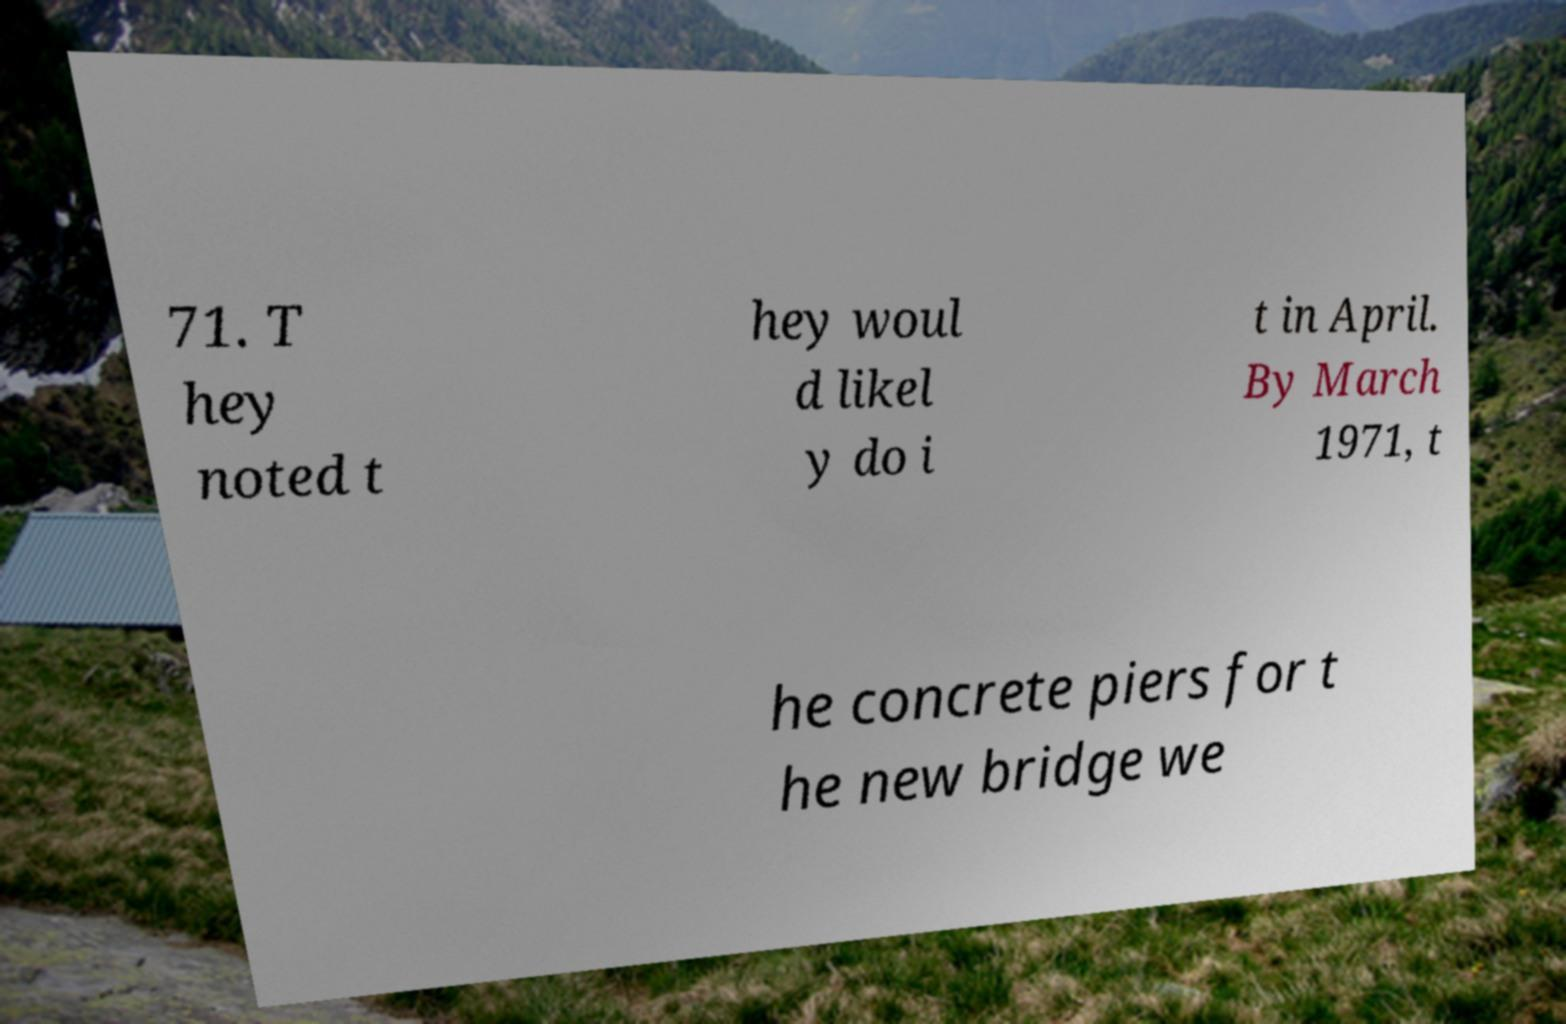I need the written content from this picture converted into text. Can you do that? 71. T hey noted t hey woul d likel y do i t in April. By March 1971, t he concrete piers for t he new bridge we 